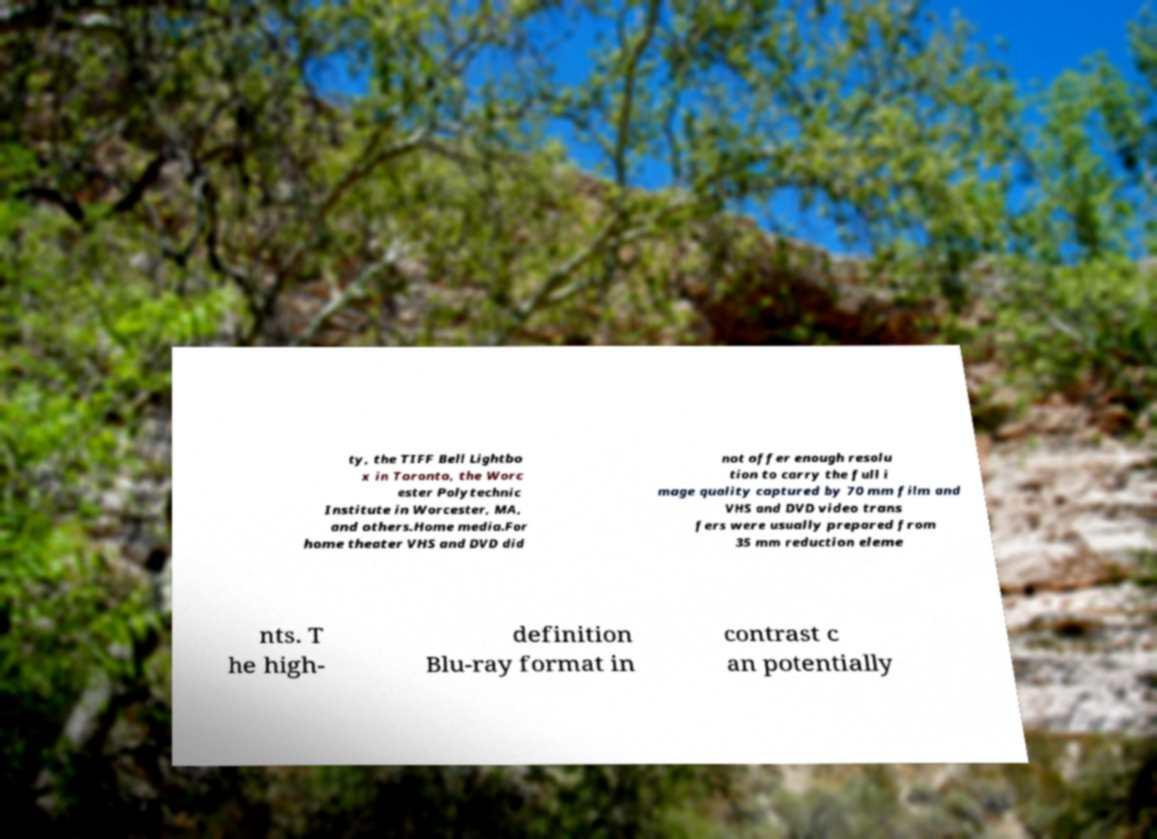I need the written content from this picture converted into text. Can you do that? ty, the TIFF Bell Lightbo x in Toronto, the Worc ester Polytechnic Institute in Worcester, MA, and others.Home media.For home theater VHS and DVD did not offer enough resolu tion to carry the full i mage quality captured by 70 mm film and VHS and DVD video trans fers were usually prepared from 35 mm reduction eleme nts. T he high- definition Blu-ray format in contrast c an potentially 